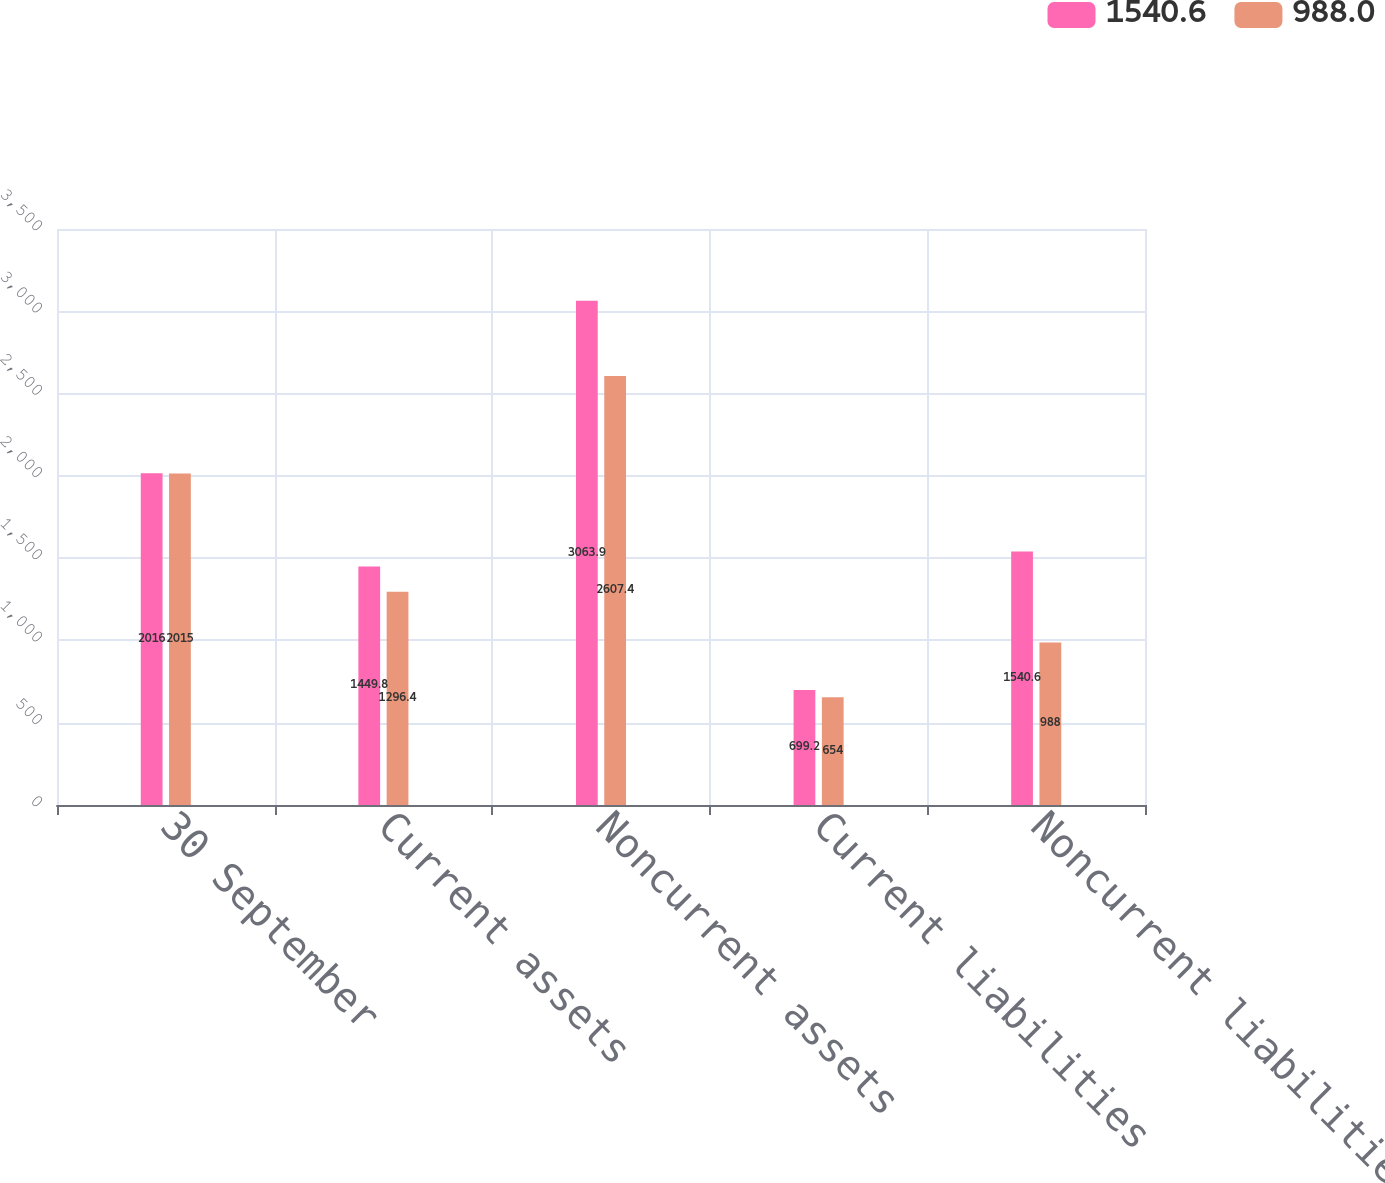<chart> <loc_0><loc_0><loc_500><loc_500><stacked_bar_chart><ecel><fcel>30 September<fcel>Current assets<fcel>Noncurrent assets<fcel>Current liabilities<fcel>Noncurrent liabilities<nl><fcel>1540.6<fcel>2016<fcel>1449.8<fcel>3063.9<fcel>699.2<fcel>1540.6<nl><fcel>988<fcel>2015<fcel>1296.4<fcel>2607.4<fcel>654<fcel>988<nl></chart> 